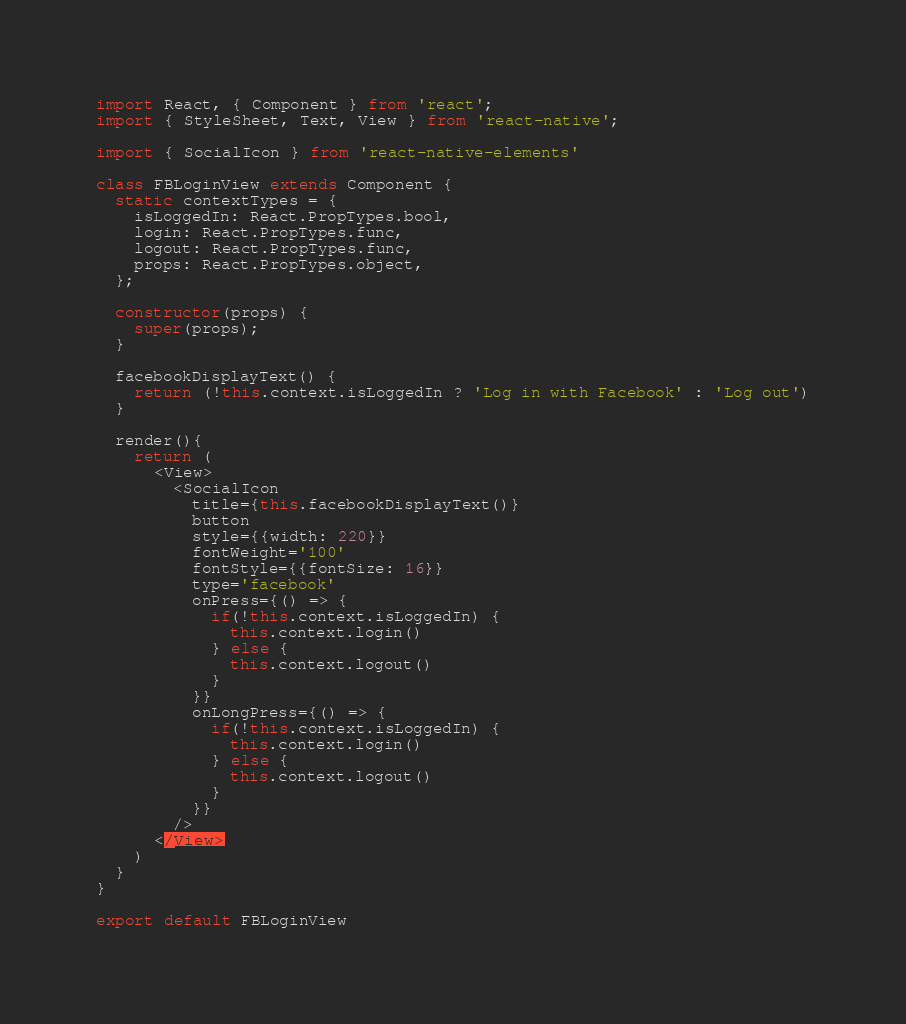<code> <loc_0><loc_0><loc_500><loc_500><_JavaScript_>import React, { Component } from 'react';
import { StyleSheet, Text, View } from 'react-native';

import { SocialIcon } from 'react-native-elements'

class FBLoginView extends Component {
  static contextTypes = {
    isLoggedIn: React.PropTypes.bool,
    login: React.PropTypes.func,
    logout: React.PropTypes.func,
    props: React.PropTypes.object,
  };

  constructor(props) {
    super(props);
  }

  facebookDisplayText() {
    return (!this.context.isLoggedIn ? 'Log in with Facebook' : 'Log out')
  }

  render(){
    return (
      <View>
        <SocialIcon
          title={this.facebookDisplayText()}
          button
          style={{width: 220}}
          fontWeight='100'
          fontStyle={{fontSize: 16}}
          type='facebook'
          onPress={() => {
            if(!this.context.isLoggedIn) {
              this.context.login()
            } else {
              this.context.logout()
            }
          }}
          onLongPress={() => {
            if(!this.context.isLoggedIn) {
              this.context.login()
            } else {
              this.context.logout()
            }
          }}
        />
      </View>
    )
  }
}

export default FBLoginView
</code> 